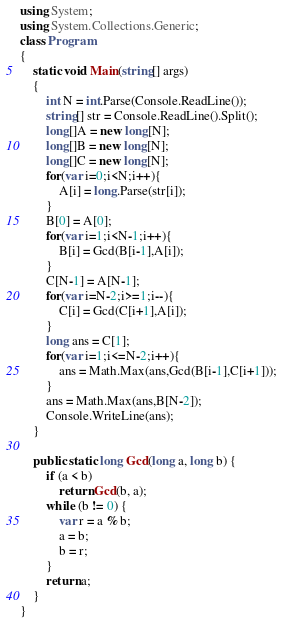Convert code to text. <code><loc_0><loc_0><loc_500><loc_500><_C#_>using System;
using System.Collections.Generic;
class Program
{
	static void Main(string[] args)
	{
		int N = int.Parse(Console.ReadLine());
		string[] str = Console.ReadLine().Split();
		long[]A = new long[N];
		long[]B = new long[N];
		long[]C = new long[N];
		for(var i=0;i<N;i++){
			A[i] = long.Parse(str[i]);
		}
		B[0] = A[0];
		for(var i=1;i<N-1;i++){
			B[i] = Gcd(B[i-1],A[i]);
		}
		C[N-1] = A[N-1];
		for(var i=N-2;i>=1;i--){
			C[i] = Gcd(C[i+1],A[i]);
		}
		long ans = C[1];
		for(var i=1;i<=N-2;i++){
			ans = Math.Max(ans,Gcd(B[i-1],C[i+1]));
		}
		ans = Math.Max(ans,B[N-2]);
		Console.WriteLine(ans);
	}
	
	public static long Gcd(long a, long b) {
		if (a < b)
			return Gcd(b, a);
		while (b != 0) {
			var r = a % b;
			a = b;
			b = r;
		}
		return a;
	}
}</code> 